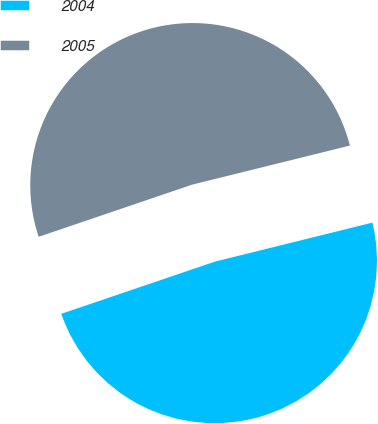Convert chart. <chart><loc_0><loc_0><loc_500><loc_500><pie_chart><fcel>2004<fcel>2005<nl><fcel>48.65%<fcel>51.35%<nl></chart> 